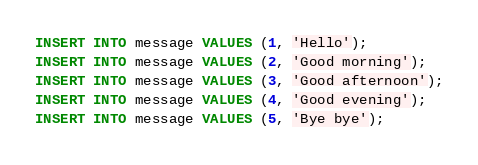<code> <loc_0><loc_0><loc_500><loc_500><_SQL_>INSERT INTO message VALUES (1, 'Hello');
INSERT INTO message VALUES (2, 'Good morning');
INSERT INTO message VALUES (3, 'Good afternoon');
INSERT INTO message VALUES (4, 'Good evening');
INSERT INTO message VALUES (5, 'Bye bye');</code> 